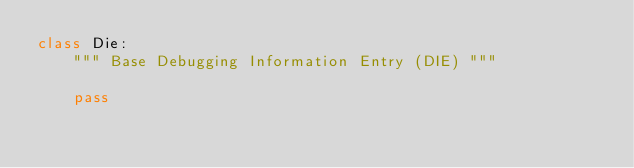Convert code to text. <code><loc_0><loc_0><loc_500><loc_500><_Python_>class Die:
    """ Base Debugging Information Entry (DIE) """

    pass
</code> 